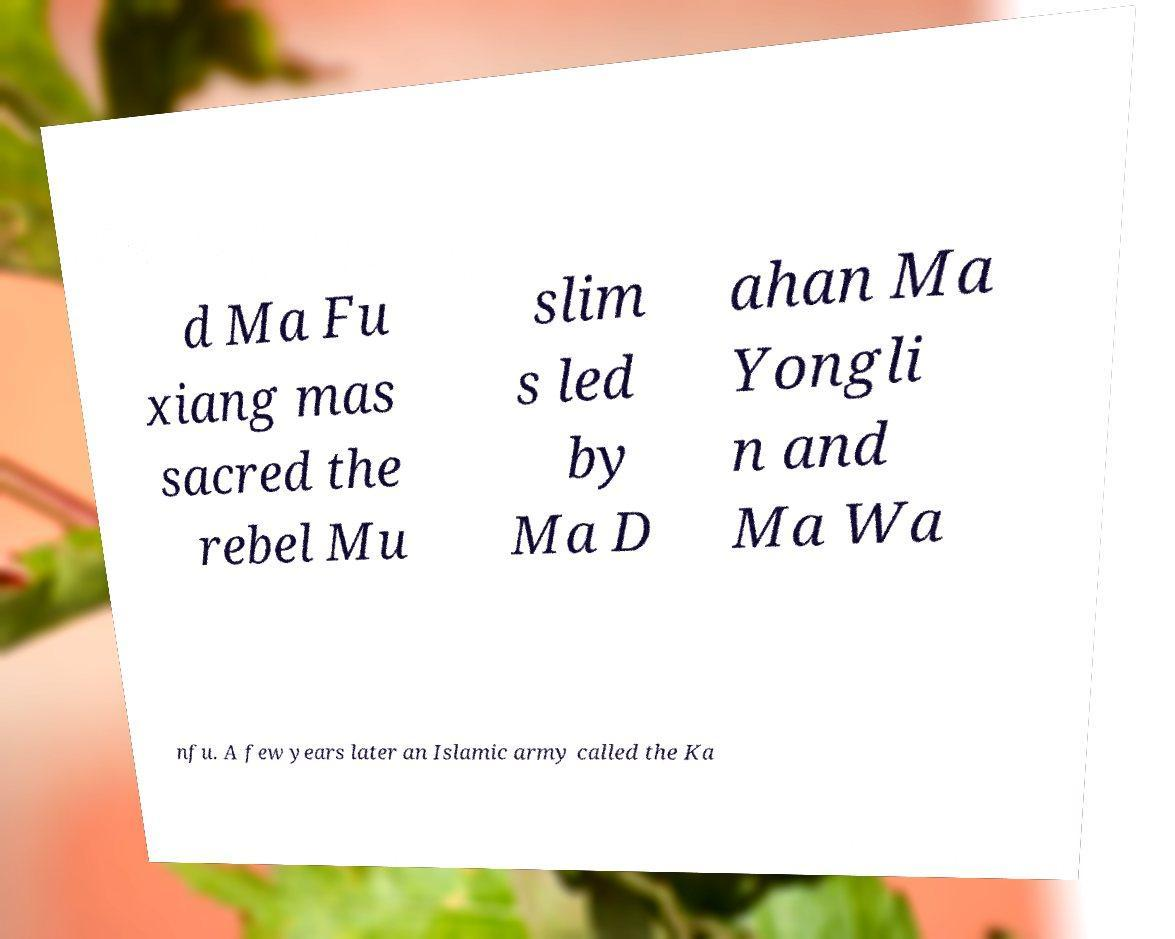Please read and relay the text visible in this image. What does it say? d Ma Fu xiang mas sacred the rebel Mu slim s led by Ma D ahan Ma Yongli n and Ma Wa nfu. A few years later an Islamic army called the Ka 